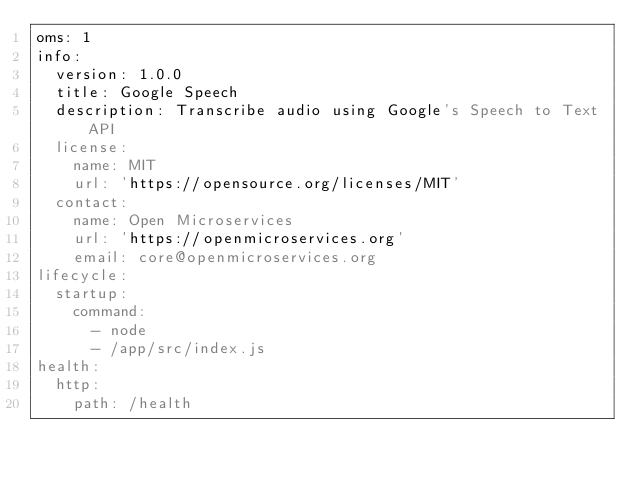Convert code to text. <code><loc_0><loc_0><loc_500><loc_500><_YAML_>oms: 1
info:
  version: 1.0.0
  title: Google Speech
  description: Transcribe audio using Google's Speech to Text API
  license:
    name: MIT
    url: 'https://opensource.org/licenses/MIT'
  contact:
    name: Open Microservices
    url: 'https://openmicroservices.org'
    email: core@openmicroservices.org
lifecycle:
  startup:
    command:
      - node
      - /app/src/index.js
health:
  http:
    path: /health</code> 